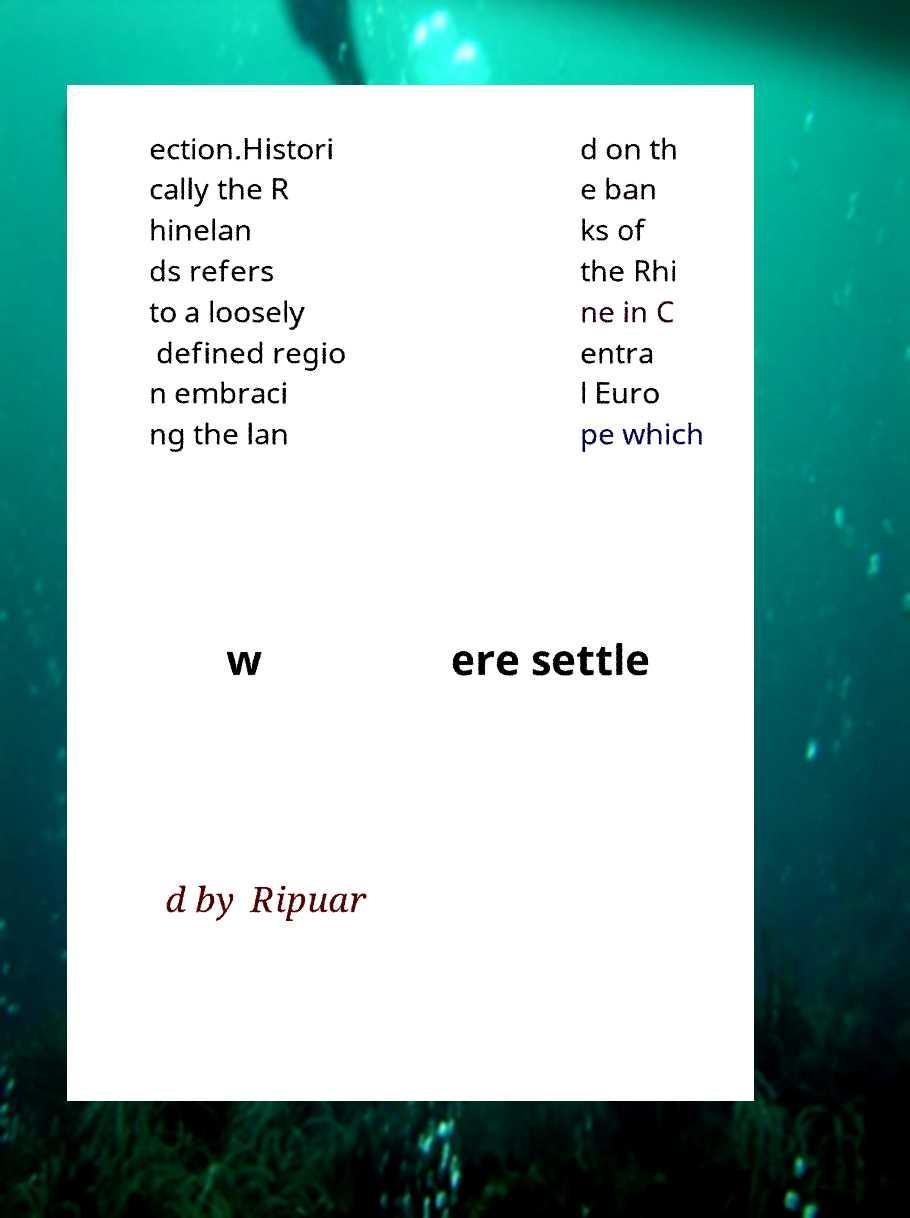Could you assist in decoding the text presented in this image and type it out clearly? ection.Histori cally the R hinelan ds refers to a loosely defined regio n embraci ng the lan d on th e ban ks of the Rhi ne in C entra l Euro pe which w ere settle d by Ripuar 